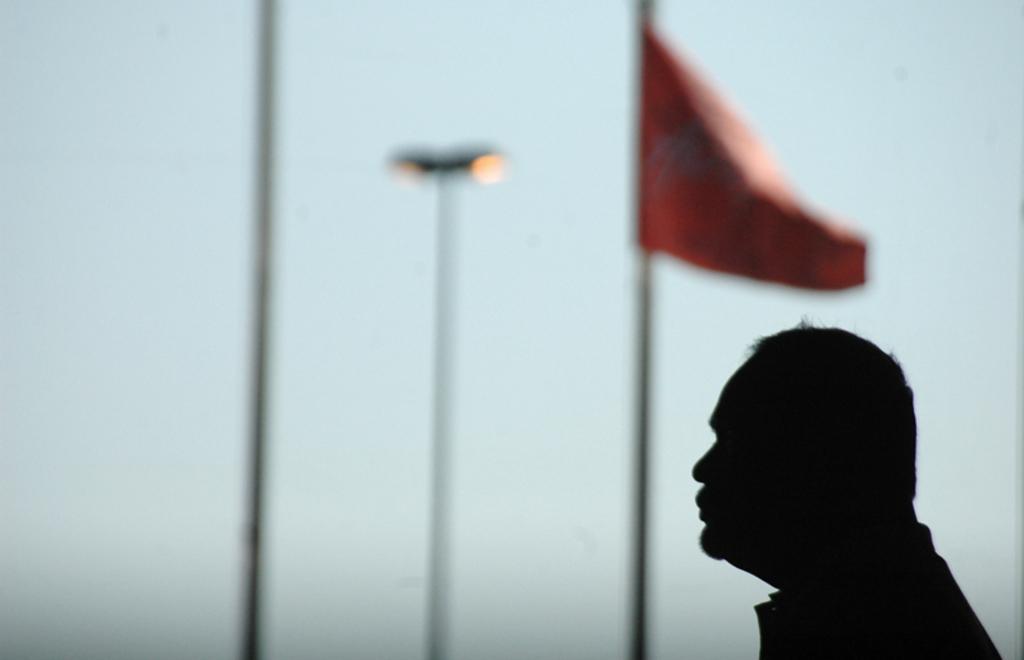Describe this image in one or two sentences. There is a person standing in front of a flag,the background of the person is blur. 